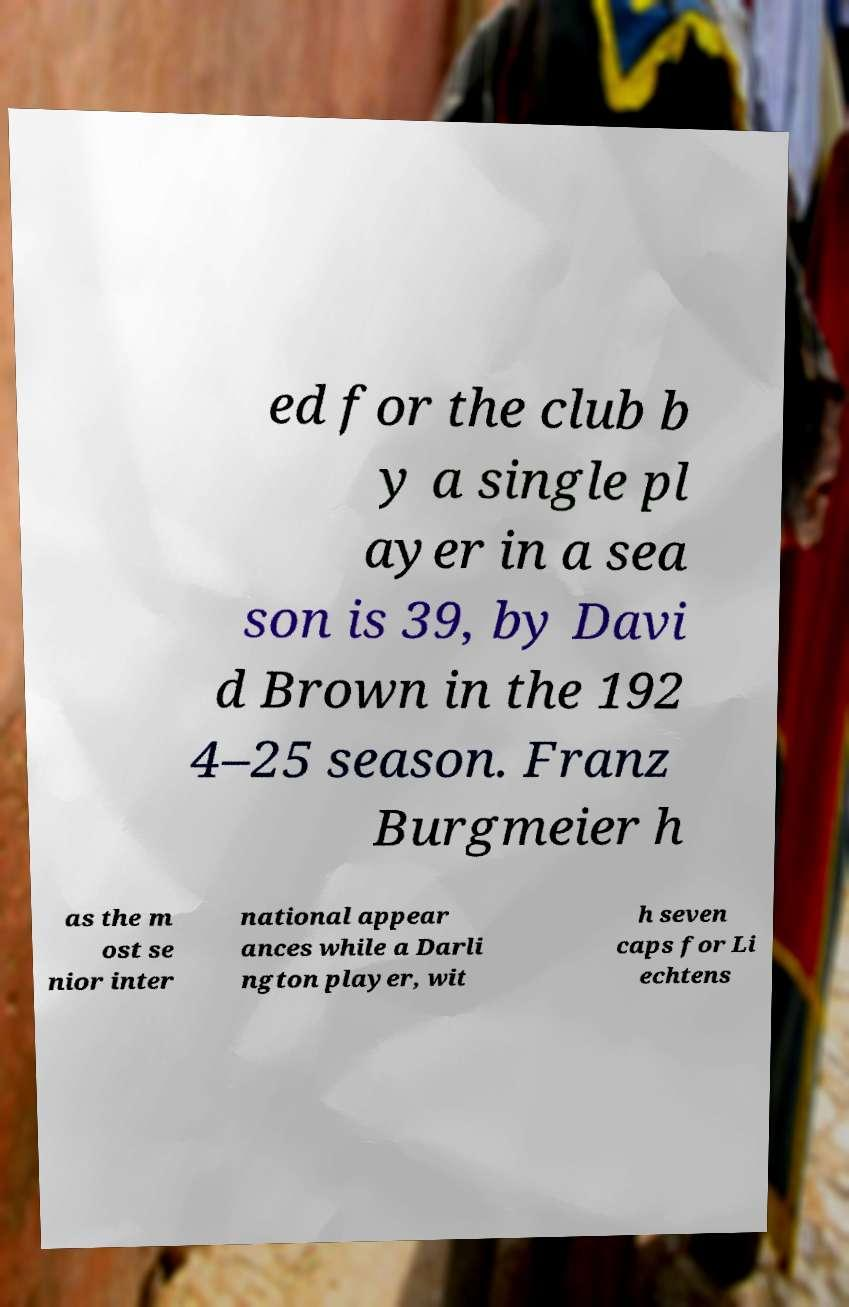I need the written content from this picture converted into text. Can you do that? ed for the club b y a single pl ayer in a sea son is 39, by Davi d Brown in the 192 4–25 season. Franz Burgmeier h as the m ost se nior inter national appear ances while a Darli ngton player, wit h seven caps for Li echtens 